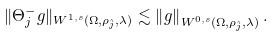Convert formula to latex. <formula><loc_0><loc_0><loc_500><loc_500>\| \Theta ^ { - } _ { j } g \| _ { W ^ { 1 , s } ( \Omega , \rho _ { \hat { j } } , \lambda ) } \lesssim \left \| g \right \| _ { W ^ { 0 , s } ( \Omega , \rho _ { \hat { j } } , \lambda ) } .</formula> 